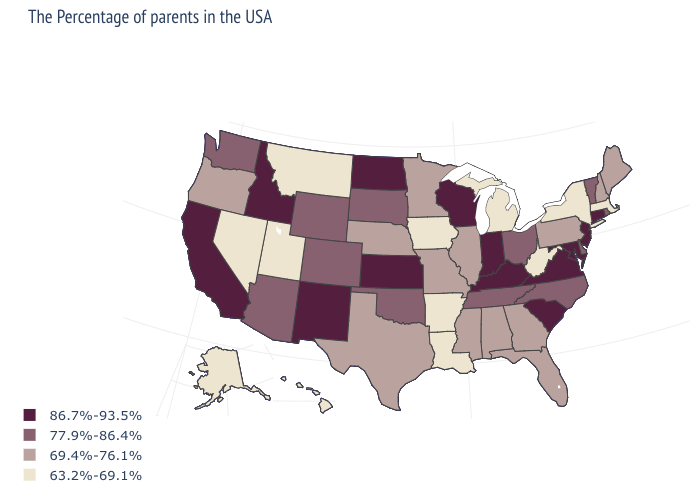Among the states that border Michigan , does Ohio have the lowest value?
Answer briefly. Yes. Name the states that have a value in the range 69.4%-76.1%?
Answer briefly. Maine, New Hampshire, Pennsylvania, Florida, Georgia, Alabama, Illinois, Mississippi, Missouri, Minnesota, Nebraska, Texas, Oregon. Name the states that have a value in the range 63.2%-69.1%?
Answer briefly. Massachusetts, New York, West Virginia, Michigan, Louisiana, Arkansas, Iowa, Utah, Montana, Nevada, Alaska, Hawaii. What is the lowest value in the USA?
Write a very short answer. 63.2%-69.1%. What is the value of New Hampshire?
Short answer required. 69.4%-76.1%. How many symbols are there in the legend?
Be succinct. 4. What is the value of Pennsylvania?
Concise answer only. 69.4%-76.1%. What is the lowest value in states that border Iowa?
Concise answer only. 69.4%-76.1%. What is the value of Montana?
Concise answer only. 63.2%-69.1%. Among the states that border North Carolina , which have the highest value?
Short answer required. Virginia, South Carolina. Does the map have missing data?
Concise answer only. No. What is the value of Ohio?
Short answer required. 77.9%-86.4%. What is the highest value in states that border Idaho?
Short answer required. 77.9%-86.4%. Name the states that have a value in the range 63.2%-69.1%?
Keep it brief. Massachusetts, New York, West Virginia, Michigan, Louisiana, Arkansas, Iowa, Utah, Montana, Nevada, Alaska, Hawaii. What is the value of Iowa?
Concise answer only. 63.2%-69.1%. 